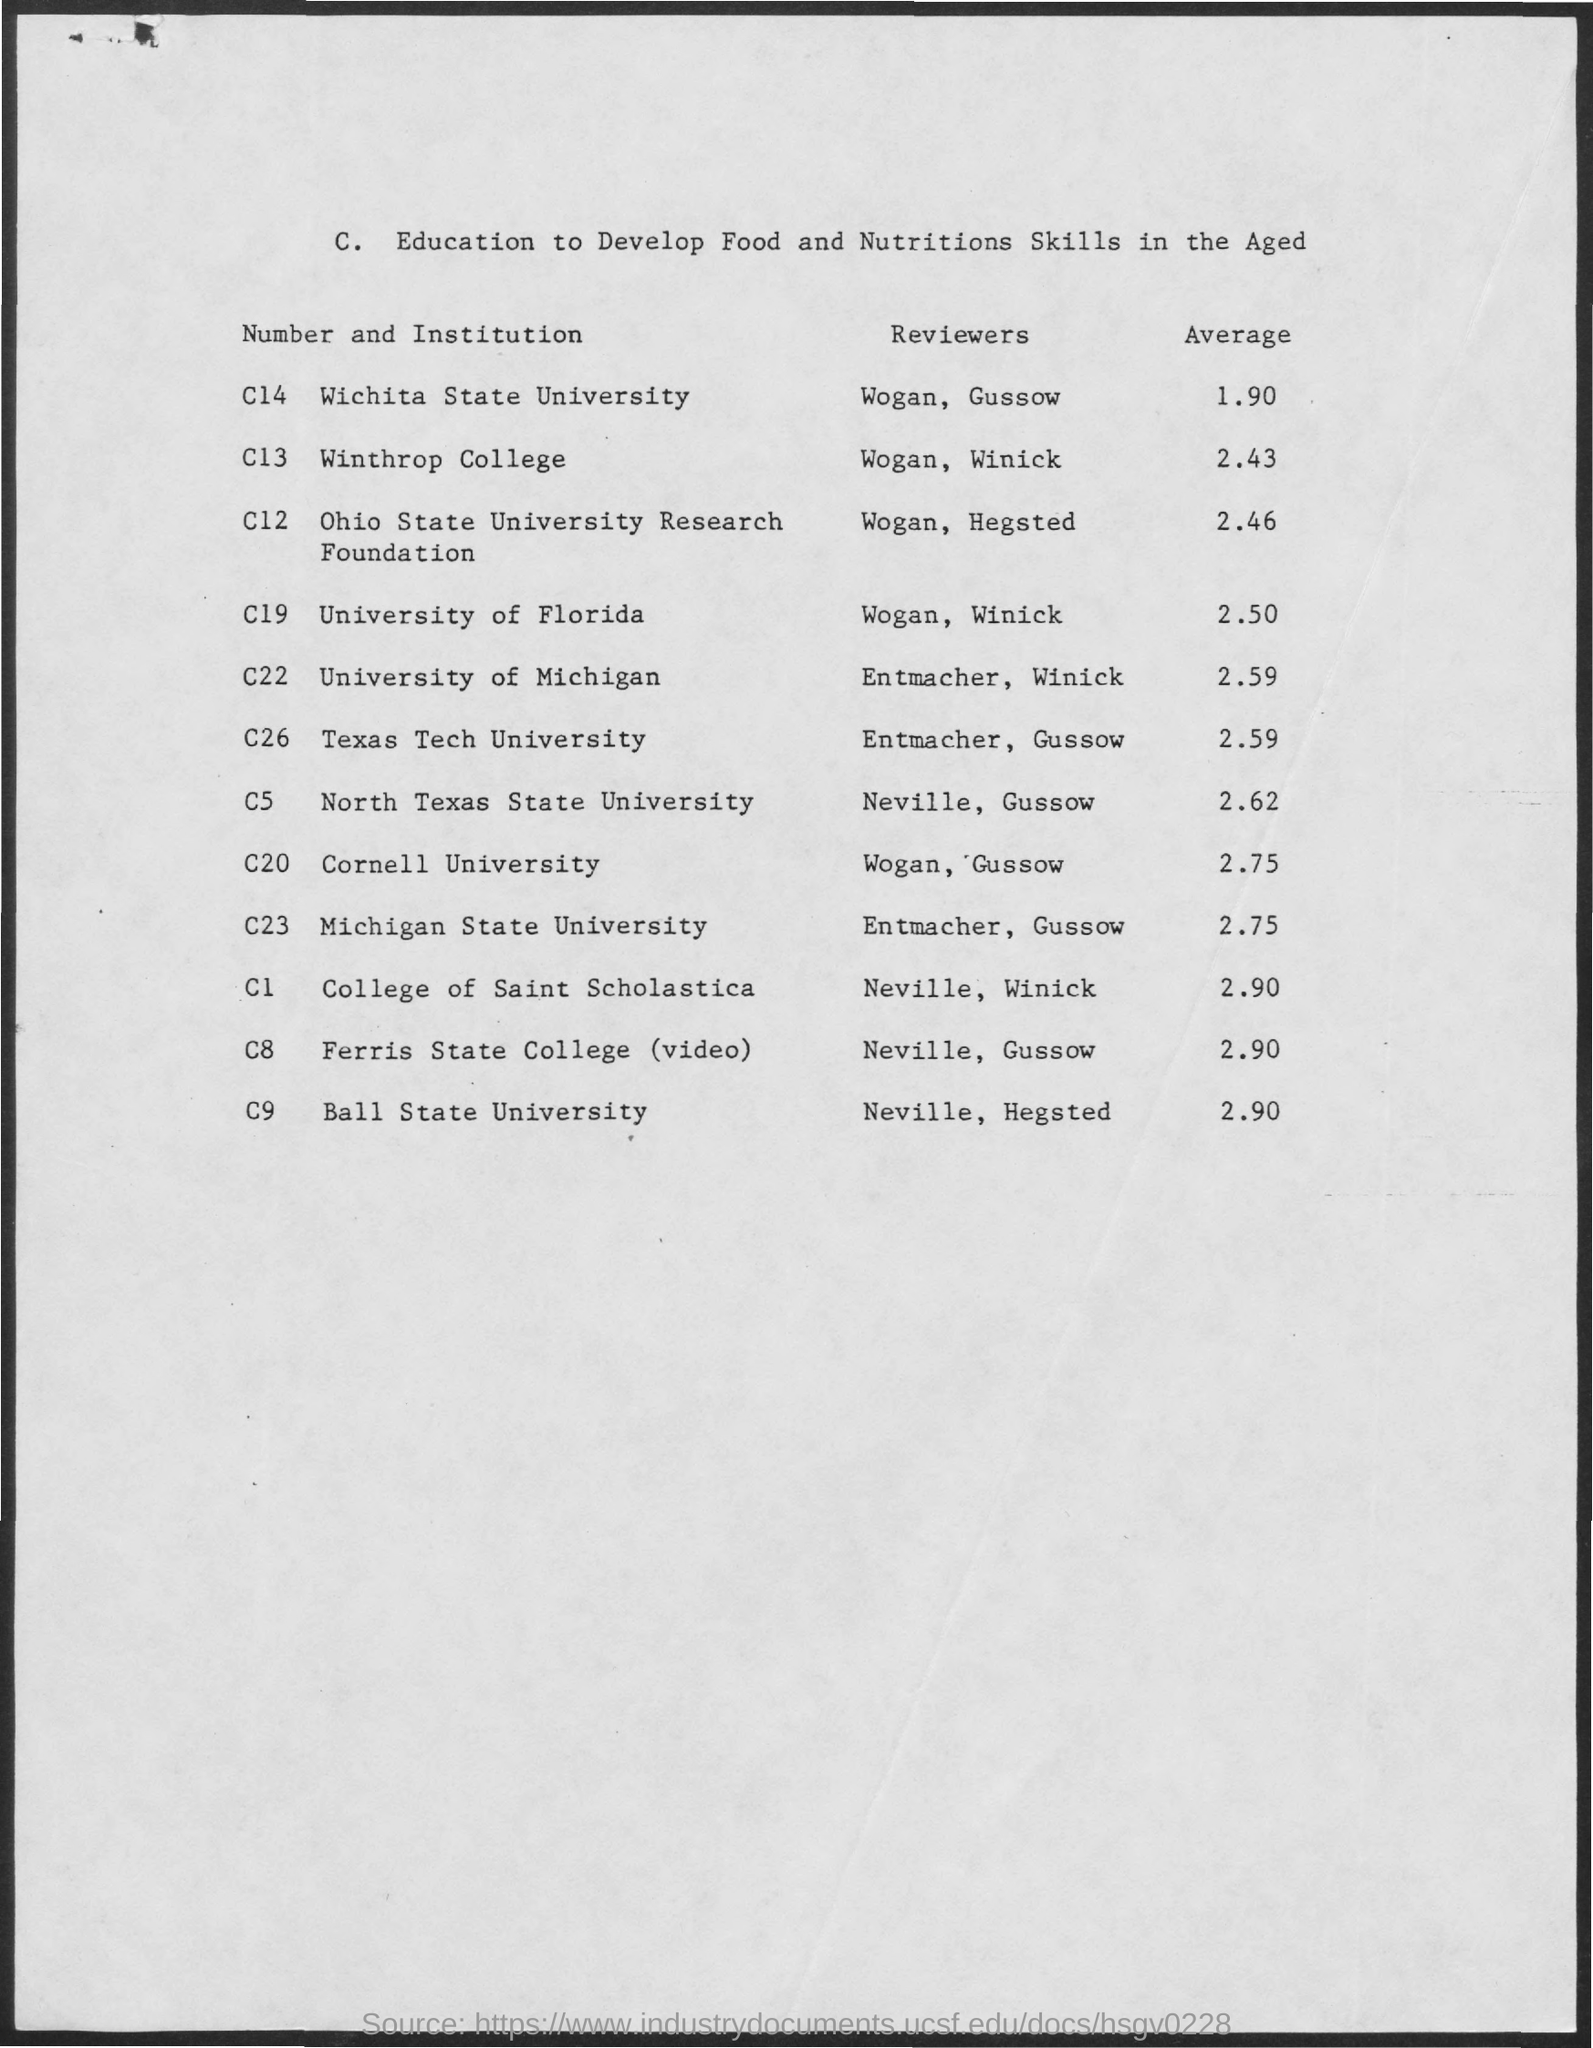List a handful of essential elements in this visual. The average GPA for the College of Saint Scholastica is 2.90. The average GPA for Wichita State University is 1.90. The average GPA for the University of Michigan is 2.59. The average GPA for Ball State University is 2.90. The average score for Michigan State University is 2.75. 